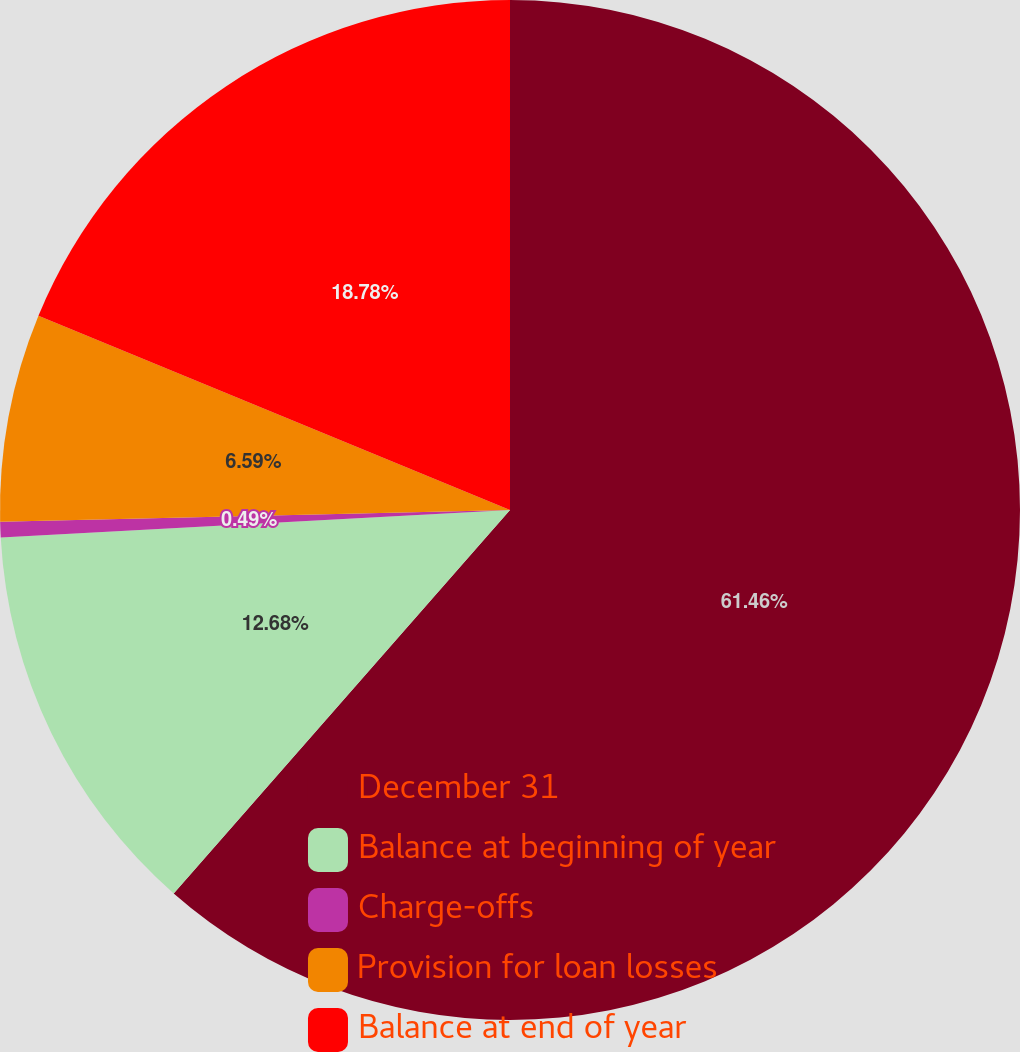<chart> <loc_0><loc_0><loc_500><loc_500><pie_chart><fcel>December 31<fcel>Balance at beginning of year<fcel>Charge-offs<fcel>Provision for loan losses<fcel>Balance at end of year<nl><fcel>61.46%<fcel>12.68%<fcel>0.49%<fcel>6.59%<fcel>18.78%<nl></chart> 